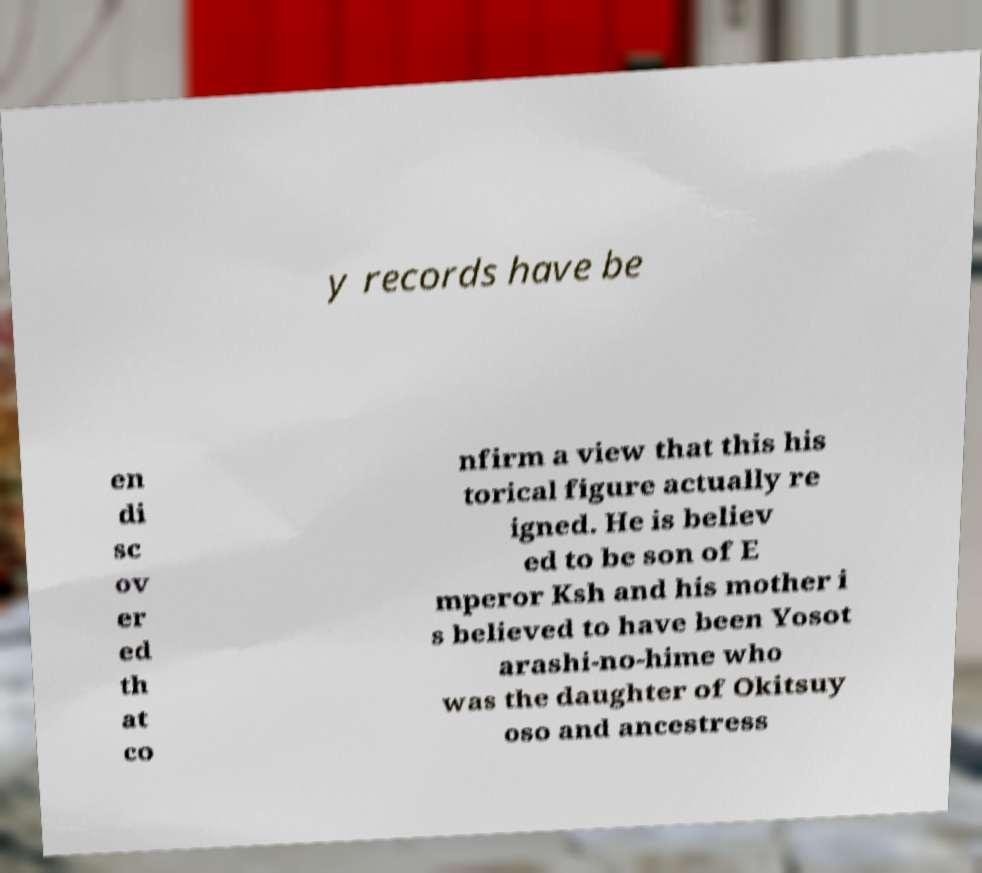Please identify and transcribe the text found in this image. y records have be en di sc ov er ed th at co nfirm a view that this his torical figure actually re igned. He is believ ed to be son of E mperor Ksh and his mother i s believed to have been Yosot arashi-no-hime who was the daughter of Okitsuy oso and ancestress 